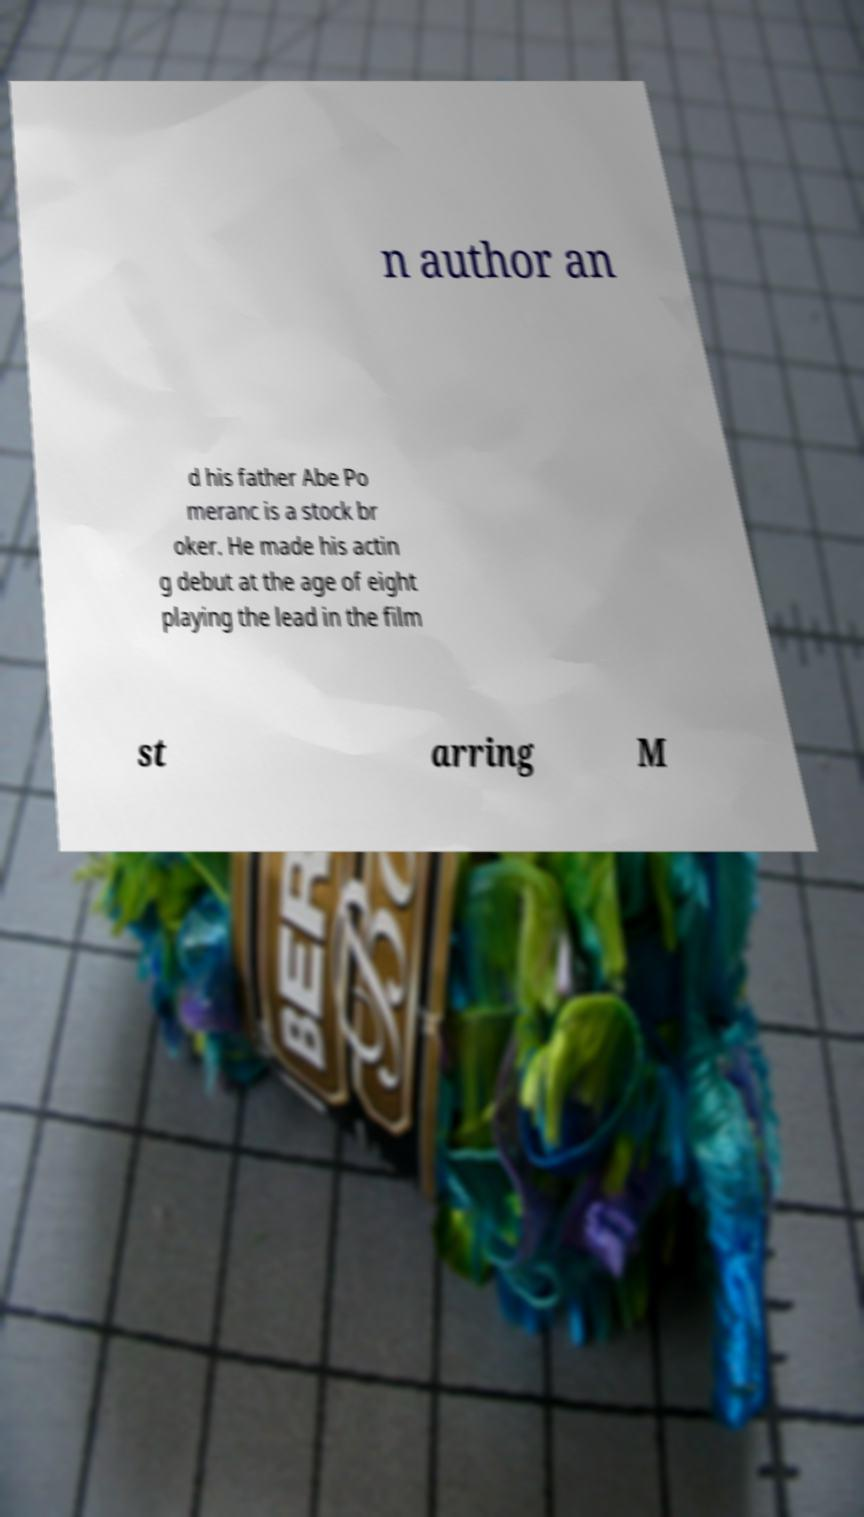Could you extract and type out the text from this image? n author an d his father Abe Po meranc is a stock br oker. He made his actin g debut at the age of eight playing the lead in the film st arring M 